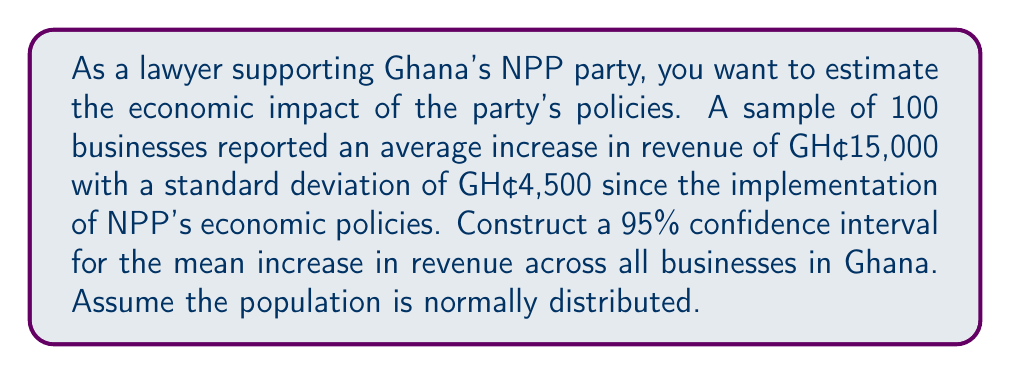Could you help me with this problem? To construct a 95% confidence interval for the mean increase in revenue, we'll follow these steps:

1. Identify the known values:
   - Sample size (n) = 100
   - Sample mean ($\bar{x}$) = GH₵15,000
   - Sample standard deviation (s) = GH₵4,500
   - Confidence level = 95% (α = 0.05)

2. Determine the critical value:
   For a 95% confidence interval with df = 99, the t-critical value is approximately 1.984 (from t-distribution table).

3. Calculate the standard error (SE) of the mean:
   $$SE = \frac{s}{\sqrt{n}} = \frac{4,500}{\sqrt{100}} = 450$$

4. Calculate the margin of error (ME):
   $$ME = t_{critical} \times SE = 1.984 \times 450 = 892.8$$

5. Construct the confidence interval:
   $$CI = \bar{x} \pm ME$$
   $$CI = 15,000 \pm 892.8$$
   $$CI = (14,107.2, 15,892.8)$$

Therefore, we can be 95% confident that the true mean increase in revenue for all businesses in Ghana due to NPP's economic policies falls between GH₵14,107.2 and GH₵15,892.8.
Answer: 95% CI: (GH₵14,107.2, GH₵15,892.8) 